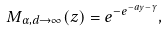<formula> <loc_0><loc_0><loc_500><loc_500>M _ { \alpha , d \to \infty } ( z ) = e ^ { - e ^ { - a y - \gamma } } ,</formula> 